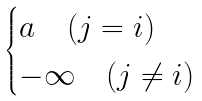Convert formula to latex. <formula><loc_0><loc_0><loc_500><loc_500>\begin{cases} a \quad ( j = i ) \\ - \infty \quad ( j \ne i ) \end{cases}</formula> 